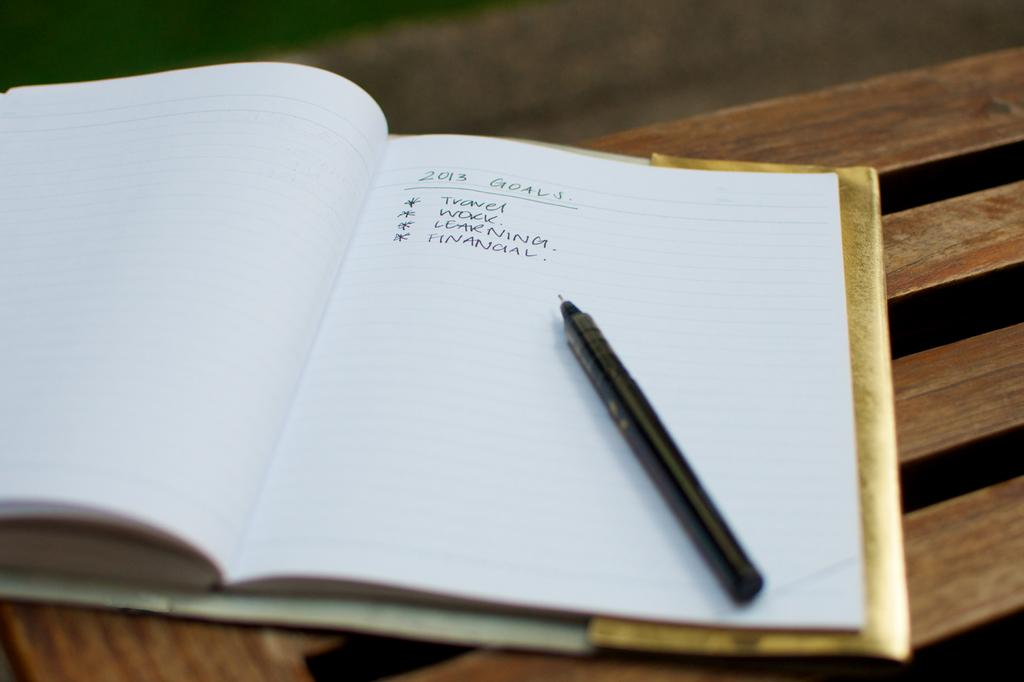What type of surface is visible in the image? There is a wooden surface in the image. What object is placed on the wooden surface? There is a book on the wooden surface. What writing instrument is also present on the wooden surface? There is a pen on the wooden surface. Can you describe any writing or markings on the wooden surface? Yes, there is text written on the wooden surface. What type of bird can be seen perched on the tree in the image? There is no tree or bird present in the image; it only features a wooden surface with a book, pen, and text. 